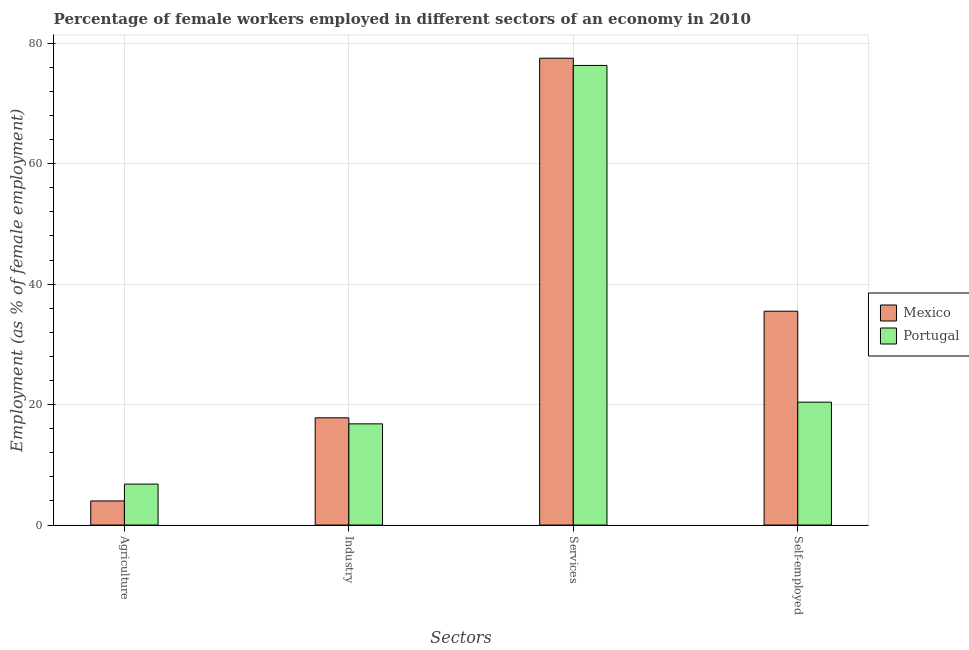How many different coloured bars are there?
Provide a short and direct response. 2. What is the label of the 3rd group of bars from the left?
Your response must be concise. Services. What is the percentage of self employed female workers in Portugal?
Your answer should be compact. 20.4. Across all countries, what is the maximum percentage of female workers in agriculture?
Ensure brevity in your answer.  6.8. Across all countries, what is the minimum percentage of female workers in services?
Make the answer very short. 76.3. What is the total percentage of self employed female workers in the graph?
Offer a terse response. 55.9. What is the difference between the percentage of female workers in agriculture in Mexico and that in Portugal?
Make the answer very short. -2.8. What is the difference between the percentage of female workers in services in Mexico and the percentage of female workers in agriculture in Portugal?
Your answer should be very brief. 70.7. What is the average percentage of self employed female workers per country?
Your answer should be compact. 27.95. What is the difference between the percentage of female workers in industry and percentage of self employed female workers in Mexico?
Offer a terse response. -17.7. What is the ratio of the percentage of self employed female workers in Portugal to that in Mexico?
Give a very brief answer. 0.57. Is the percentage of female workers in agriculture in Mexico less than that in Portugal?
Provide a succinct answer. Yes. What is the difference between the highest and the second highest percentage of self employed female workers?
Keep it short and to the point. 15.1. What is the difference between the highest and the lowest percentage of female workers in agriculture?
Ensure brevity in your answer.  2.8. What does the 1st bar from the left in Services represents?
Provide a short and direct response. Mexico. Is it the case that in every country, the sum of the percentage of female workers in agriculture and percentage of female workers in industry is greater than the percentage of female workers in services?
Keep it short and to the point. No. Are all the bars in the graph horizontal?
Your answer should be very brief. No. Does the graph contain any zero values?
Give a very brief answer. No. Does the graph contain grids?
Offer a very short reply. Yes. How many legend labels are there?
Your answer should be compact. 2. How are the legend labels stacked?
Your answer should be very brief. Vertical. What is the title of the graph?
Provide a succinct answer. Percentage of female workers employed in different sectors of an economy in 2010. What is the label or title of the X-axis?
Provide a short and direct response. Sectors. What is the label or title of the Y-axis?
Give a very brief answer. Employment (as % of female employment). What is the Employment (as % of female employment) in Portugal in Agriculture?
Give a very brief answer. 6.8. What is the Employment (as % of female employment) of Mexico in Industry?
Provide a short and direct response. 17.8. What is the Employment (as % of female employment) of Portugal in Industry?
Your response must be concise. 16.8. What is the Employment (as % of female employment) of Mexico in Services?
Make the answer very short. 77.5. What is the Employment (as % of female employment) in Portugal in Services?
Provide a short and direct response. 76.3. What is the Employment (as % of female employment) in Mexico in Self-employed?
Ensure brevity in your answer.  35.5. What is the Employment (as % of female employment) in Portugal in Self-employed?
Offer a very short reply. 20.4. Across all Sectors, what is the maximum Employment (as % of female employment) in Mexico?
Keep it short and to the point. 77.5. Across all Sectors, what is the maximum Employment (as % of female employment) in Portugal?
Provide a succinct answer. 76.3. Across all Sectors, what is the minimum Employment (as % of female employment) in Mexico?
Your answer should be compact. 4. Across all Sectors, what is the minimum Employment (as % of female employment) in Portugal?
Offer a terse response. 6.8. What is the total Employment (as % of female employment) in Mexico in the graph?
Provide a short and direct response. 134.8. What is the total Employment (as % of female employment) of Portugal in the graph?
Provide a short and direct response. 120.3. What is the difference between the Employment (as % of female employment) in Mexico in Agriculture and that in Services?
Offer a terse response. -73.5. What is the difference between the Employment (as % of female employment) in Portugal in Agriculture and that in Services?
Ensure brevity in your answer.  -69.5. What is the difference between the Employment (as % of female employment) of Mexico in Agriculture and that in Self-employed?
Provide a short and direct response. -31.5. What is the difference between the Employment (as % of female employment) in Portugal in Agriculture and that in Self-employed?
Offer a very short reply. -13.6. What is the difference between the Employment (as % of female employment) of Mexico in Industry and that in Services?
Provide a succinct answer. -59.7. What is the difference between the Employment (as % of female employment) in Portugal in Industry and that in Services?
Your response must be concise. -59.5. What is the difference between the Employment (as % of female employment) in Mexico in Industry and that in Self-employed?
Give a very brief answer. -17.7. What is the difference between the Employment (as % of female employment) of Mexico in Services and that in Self-employed?
Keep it short and to the point. 42. What is the difference between the Employment (as % of female employment) of Portugal in Services and that in Self-employed?
Provide a short and direct response. 55.9. What is the difference between the Employment (as % of female employment) of Mexico in Agriculture and the Employment (as % of female employment) of Portugal in Services?
Your response must be concise. -72.3. What is the difference between the Employment (as % of female employment) of Mexico in Agriculture and the Employment (as % of female employment) of Portugal in Self-employed?
Provide a short and direct response. -16.4. What is the difference between the Employment (as % of female employment) in Mexico in Industry and the Employment (as % of female employment) in Portugal in Services?
Your response must be concise. -58.5. What is the difference between the Employment (as % of female employment) in Mexico in Industry and the Employment (as % of female employment) in Portugal in Self-employed?
Offer a terse response. -2.6. What is the difference between the Employment (as % of female employment) in Mexico in Services and the Employment (as % of female employment) in Portugal in Self-employed?
Make the answer very short. 57.1. What is the average Employment (as % of female employment) in Mexico per Sectors?
Your answer should be compact. 33.7. What is the average Employment (as % of female employment) of Portugal per Sectors?
Provide a short and direct response. 30.07. What is the difference between the Employment (as % of female employment) in Mexico and Employment (as % of female employment) in Portugal in Services?
Make the answer very short. 1.2. What is the difference between the Employment (as % of female employment) of Mexico and Employment (as % of female employment) of Portugal in Self-employed?
Provide a succinct answer. 15.1. What is the ratio of the Employment (as % of female employment) of Mexico in Agriculture to that in Industry?
Provide a succinct answer. 0.22. What is the ratio of the Employment (as % of female employment) of Portugal in Agriculture to that in Industry?
Provide a succinct answer. 0.4. What is the ratio of the Employment (as % of female employment) of Mexico in Agriculture to that in Services?
Provide a succinct answer. 0.05. What is the ratio of the Employment (as % of female employment) in Portugal in Agriculture to that in Services?
Offer a terse response. 0.09. What is the ratio of the Employment (as % of female employment) of Mexico in Agriculture to that in Self-employed?
Provide a short and direct response. 0.11. What is the ratio of the Employment (as % of female employment) in Portugal in Agriculture to that in Self-employed?
Provide a short and direct response. 0.33. What is the ratio of the Employment (as % of female employment) of Mexico in Industry to that in Services?
Your response must be concise. 0.23. What is the ratio of the Employment (as % of female employment) in Portugal in Industry to that in Services?
Your answer should be very brief. 0.22. What is the ratio of the Employment (as % of female employment) of Mexico in Industry to that in Self-employed?
Provide a succinct answer. 0.5. What is the ratio of the Employment (as % of female employment) in Portugal in Industry to that in Self-employed?
Keep it short and to the point. 0.82. What is the ratio of the Employment (as % of female employment) of Mexico in Services to that in Self-employed?
Make the answer very short. 2.18. What is the ratio of the Employment (as % of female employment) of Portugal in Services to that in Self-employed?
Your answer should be very brief. 3.74. What is the difference between the highest and the second highest Employment (as % of female employment) in Mexico?
Your answer should be compact. 42. What is the difference between the highest and the second highest Employment (as % of female employment) of Portugal?
Keep it short and to the point. 55.9. What is the difference between the highest and the lowest Employment (as % of female employment) in Mexico?
Provide a succinct answer. 73.5. What is the difference between the highest and the lowest Employment (as % of female employment) in Portugal?
Keep it short and to the point. 69.5. 